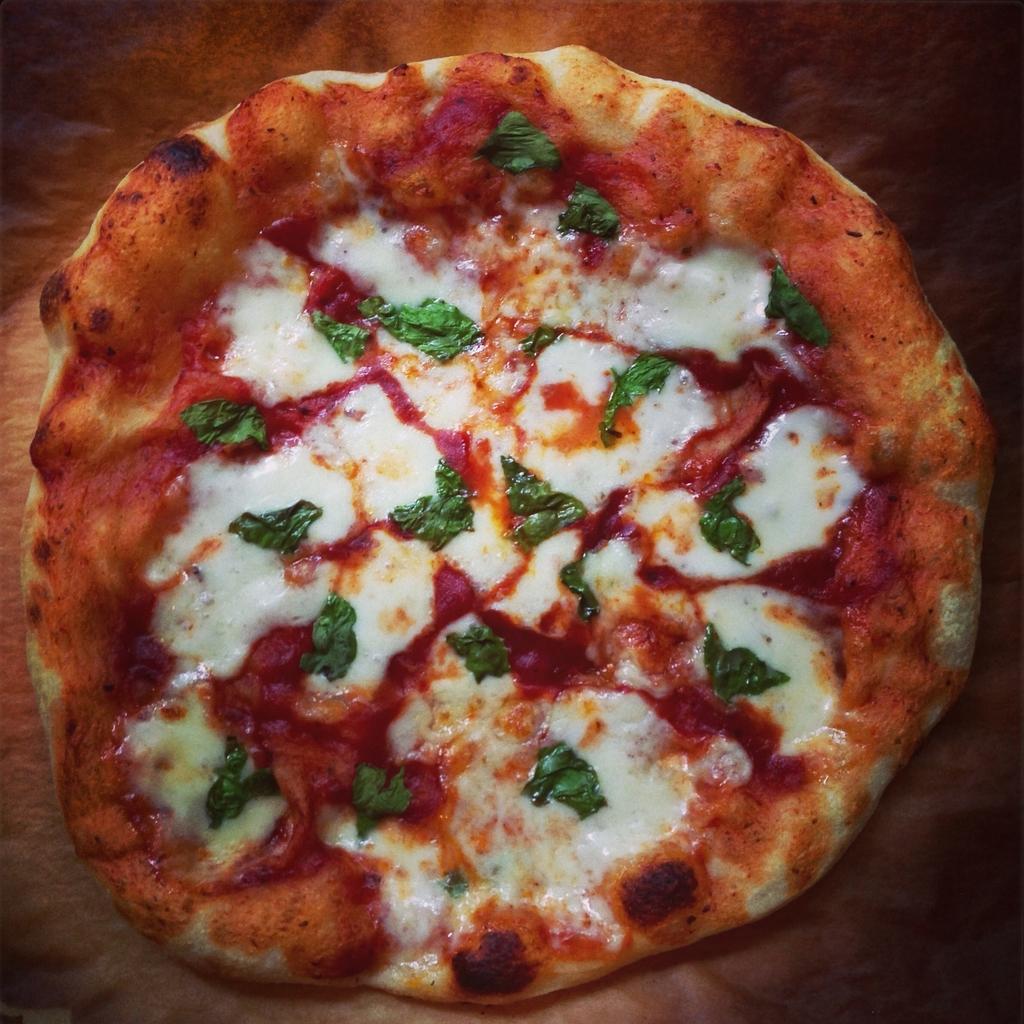What type of food is visible in the image? There is a pizza in the image. On what surface is the pizza placed? The pizza is on a wooden surface. What type of crack can be heard in the image? There is no cracking sound present in the image, as it features a pizza on a wooden surface. What type of structure is visible in the image? The image does not show any specific structure; it only features a pizza on a wooden surface. 